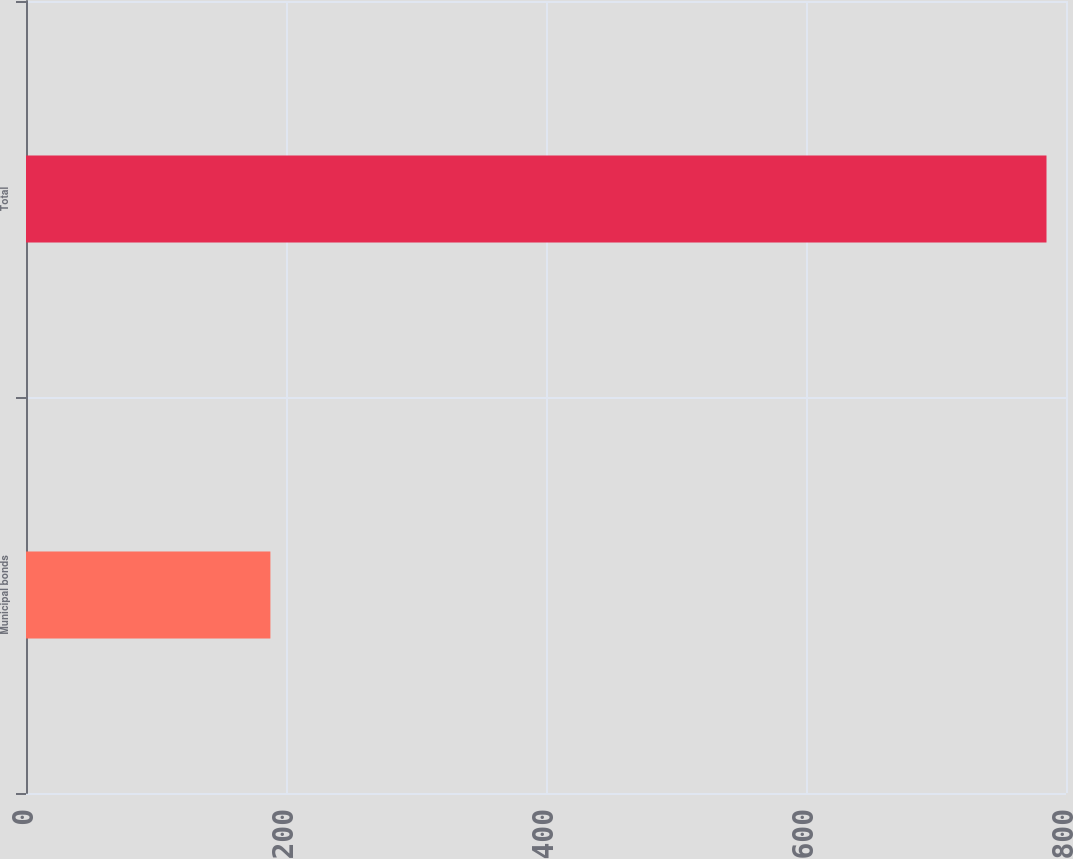Convert chart to OTSL. <chart><loc_0><loc_0><loc_500><loc_500><bar_chart><fcel>Municipal bonds<fcel>Total<nl><fcel>188<fcel>785<nl></chart> 